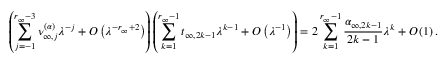<formula> <loc_0><loc_0><loc_500><loc_500>\left ( \sum _ { j = - 1 } ^ { r _ { \infty } - 3 } \nu _ { \infty , j } ^ { ( \alpha ) } \lambda ^ { - j } + O \left ( \lambda ^ { - r _ { \infty } + 2 } \right ) \right ) \left ( \sum _ { k = 1 } ^ { r _ { \infty } - 1 } t _ { \infty , 2 k - 1 } \lambda ^ { k - 1 } + O \left ( \lambda ^ { - 1 } \right ) \right ) = 2 \sum _ { k = 1 } ^ { r _ { \infty } - 1 } \frac { \alpha _ { \infty , 2 k - 1 } } { 2 k - 1 } \lambda ^ { k } + O \left ( 1 \right ) .</formula> 